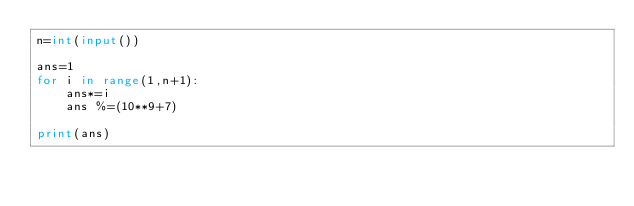Convert code to text. <code><loc_0><loc_0><loc_500><loc_500><_Python_>n=int(input())

ans=1
for i in range(1,n+1):
    ans*=i
    ans %=(10**9+7)
    
print(ans)    </code> 